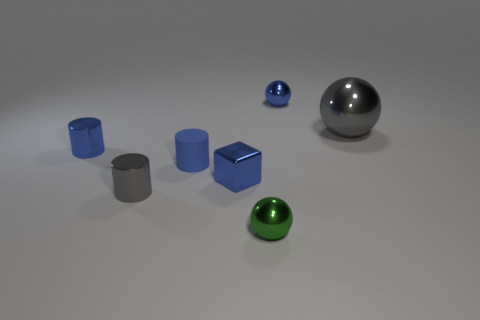Add 3 blue metal cylinders. How many objects exist? 10 Subtract all cylinders. How many objects are left? 4 Add 7 tiny gray cylinders. How many tiny gray cylinders exist? 8 Subtract 0 yellow spheres. How many objects are left? 7 Subtract all small blue metal things. Subtract all large brown matte objects. How many objects are left? 4 Add 4 small matte objects. How many small matte objects are left? 5 